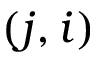<formula> <loc_0><loc_0><loc_500><loc_500>( j , i )</formula> 